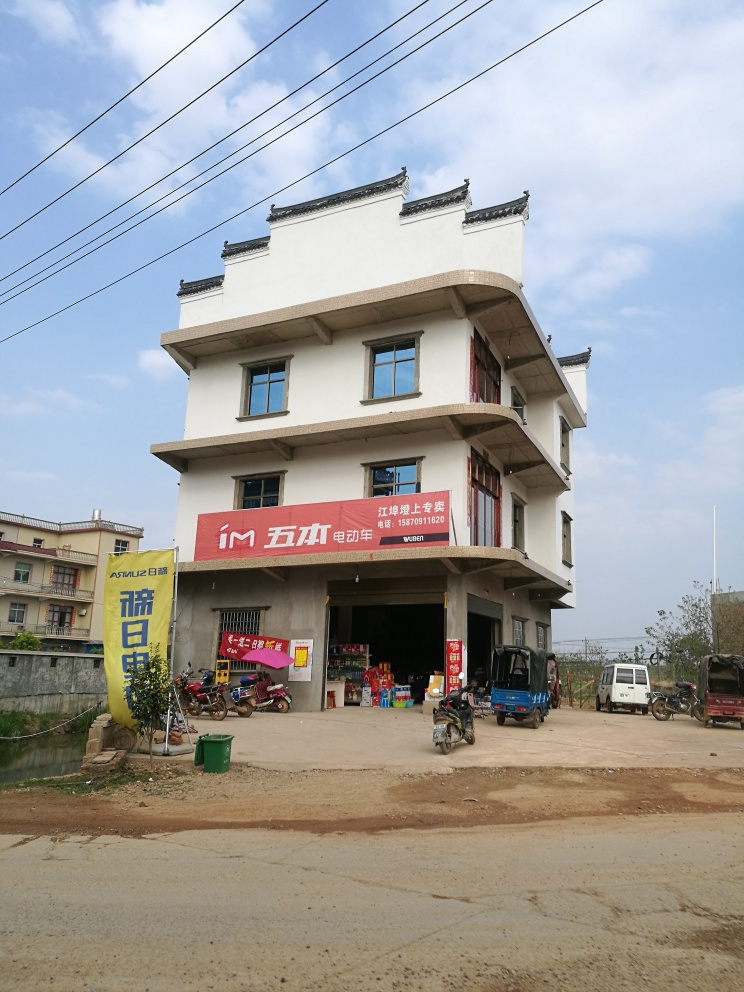Are there any focus issues in the image? After reviewing the image, it appears that the photo is clear with distinct and sharp details observable throughout various elements in the scene, such as the text on the banners, the architectural features, and vehicles. Therefore, I confirm that there are no focus issues in this image. 